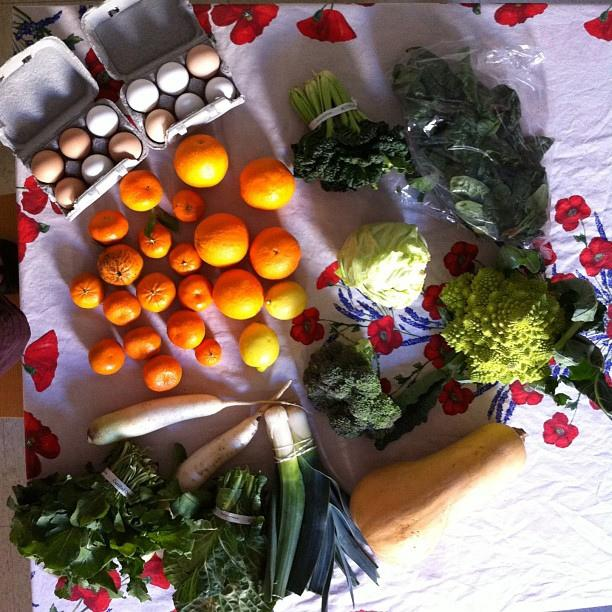Why are the eggs placed in the container?

Choices:
A) protection
B) to cook
C) to eat
D) to dye protection 